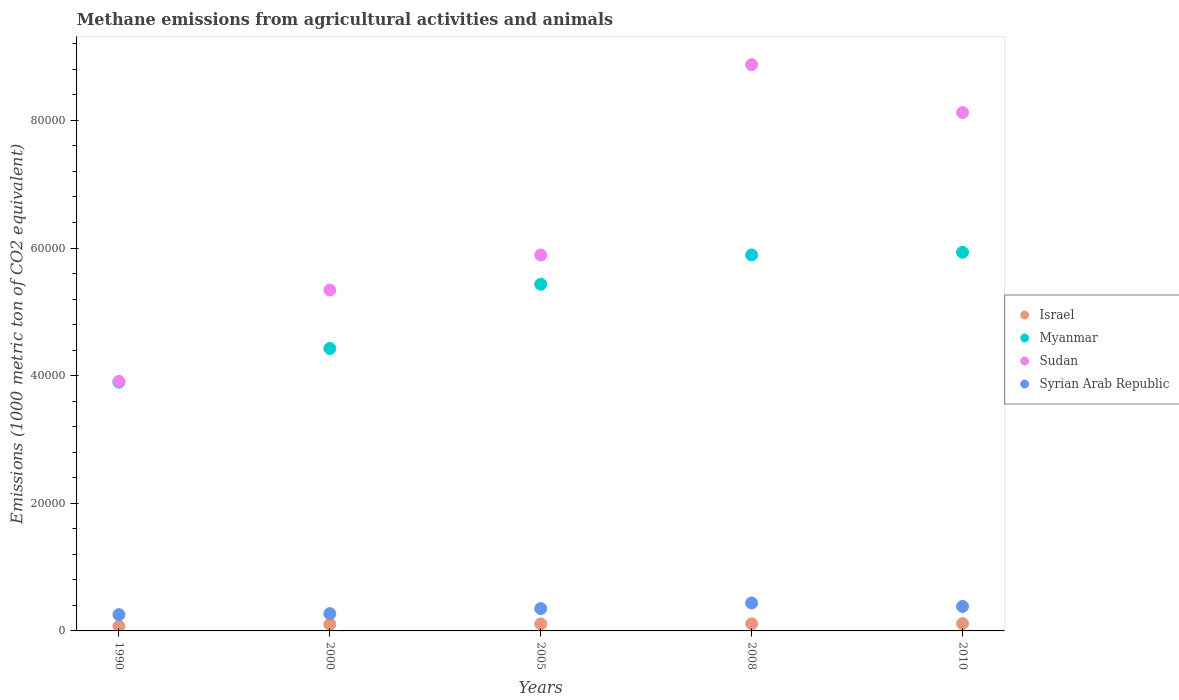Is the number of dotlines equal to the number of legend labels?
Offer a terse response. Yes. What is the amount of methane emitted in Syrian Arab Republic in 2000?
Provide a succinct answer. 2708.8. Across all years, what is the maximum amount of methane emitted in Israel?
Provide a succinct answer. 1145.5. Across all years, what is the minimum amount of methane emitted in Israel?
Your answer should be compact. 737.7. What is the total amount of methane emitted in Israel in the graph?
Give a very brief answer. 5140.4. What is the difference between the amount of methane emitted in Myanmar in 1990 and that in 2000?
Your answer should be compact. -5282. What is the difference between the amount of methane emitted in Sudan in 2000 and the amount of methane emitted in Syrian Arab Republic in 2010?
Your response must be concise. 4.96e+04. What is the average amount of methane emitted in Myanmar per year?
Offer a terse response. 5.12e+04. In the year 2005, what is the difference between the amount of methane emitted in Myanmar and amount of methane emitted in Sudan?
Provide a succinct answer. -4577.7. In how many years, is the amount of methane emitted in Myanmar greater than 4000 1000 metric ton?
Your answer should be very brief. 5. What is the ratio of the amount of methane emitted in Israel in 1990 to that in 2008?
Your answer should be compact. 0.66. Is the amount of methane emitted in Syrian Arab Republic in 1990 less than that in 2010?
Your response must be concise. Yes. Is the difference between the amount of methane emitted in Myanmar in 2000 and 2008 greater than the difference between the amount of methane emitted in Sudan in 2000 and 2008?
Ensure brevity in your answer.  Yes. What is the difference between the highest and the second highest amount of methane emitted in Sudan?
Offer a very short reply. 7508.4. What is the difference between the highest and the lowest amount of methane emitted in Sudan?
Offer a terse response. 4.96e+04. In how many years, is the amount of methane emitted in Israel greater than the average amount of methane emitted in Israel taken over all years?
Provide a short and direct response. 4. Is it the case that in every year, the sum of the amount of methane emitted in Sudan and amount of methane emitted in Syrian Arab Republic  is greater than the amount of methane emitted in Israel?
Your answer should be very brief. Yes. Is the amount of methane emitted in Israel strictly less than the amount of methane emitted in Myanmar over the years?
Give a very brief answer. Yes. How many dotlines are there?
Offer a very short reply. 4. How many years are there in the graph?
Offer a very short reply. 5. Does the graph contain any zero values?
Make the answer very short. No. What is the title of the graph?
Offer a very short reply. Methane emissions from agricultural activities and animals. What is the label or title of the Y-axis?
Your answer should be very brief. Emissions (1000 metric ton of CO2 equivalent). What is the Emissions (1000 metric ton of CO2 equivalent) of Israel in 1990?
Offer a terse response. 737.7. What is the Emissions (1000 metric ton of CO2 equivalent) in Myanmar in 1990?
Make the answer very short. 3.90e+04. What is the Emissions (1000 metric ton of CO2 equivalent) of Sudan in 1990?
Make the answer very short. 3.91e+04. What is the Emissions (1000 metric ton of CO2 equivalent) of Syrian Arab Republic in 1990?
Provide a succinct answer. 2551.7. What is the Emissions (1000 metric ton of CO2 equivalent) of Israel in 2000?
Your response must be concise. 1041.6. What is the Emissions (1000 metric ton of CO2 equivalent) in Myanmar in 2000?
Your answer should be compact. 4.43e+04. What is the Emissions (1000 metric ton of CO2 equivalent) in Sudan in 2000?
Provide a succinct answer. 5.34e+04. What is the Emissions (1000 metric ton of CO2 equivalent) of Syrian Arab Republic in 2000?
Provide a short and direct response. 2708.8. What is the Emissions (1000 metric ton of CO2 equivalent) in Israel in 2005?
Keep it short and to the point. 1095.9. What is the Emissions (1000 metric ton of CO2 equivalent) of Myanmar in 2005?
Provide a succinct answer. 5.43e+04. What is the Emissions (1000 metric ton of CO2 equivalent) of Sudan in 2005?
Your answer should be very brief. 5.89e+04. What is the Emissions (1000 metric ton of CO2 equivalent) of Syrian Arab Republic in 2005?
Your answer should be compact. 3498.3. What is the Emissions (1000 metric ton of CO2 equivalent) of Israel in 2008?
Make the answer very short. 1119.7. What is the Emissions (1000 metric ton of CO2 equivalent) in Myanmar in 2008?
Provide a short and direct response. 5.89e+04. What is the Emissions (1000 metric ton of CO2 equivalent) of Sudan in 2008?
Ensure brevity in your answer.  8.87e+04. What is the Emissions (1000 metric ton of CO2 equivalent) in Syrian Arab Republic in 2008?
Your answer should be compact. 4376.8. What is the Emissions (1000 metric ton of CO2 equivalent) of Israel in 2010?
Your answer should be compact. 1145.5. What is the Emissions (1000 metric ton of CO2 equivalent) in Myanmar in 2010?
Ensure brevity in your answer.  5.93e+04. What is the Emissions (1000 metric ton of CO2 equivalent) in Sudan in 2010?
Offer a very short reply. 8.12e+04. What is the Emissions (1000 metric ton of CO2 equivalent) of Syrian Arab Republic in 2010?
Your answer should be very brief. 3839.8. Across all years, what is the maximum Emissions (1000 metric ton of CO2 equivalent) of Israel?
Offer a very short reply. 1145.5. Across all years, what is the maximum Emissions (1000 metric ton of CO2 equivalent) in Myanmar?
Make the answer very short. 5.93e+04. Across all years, what is the maximum Emissions (1000 metric ton of CO2 equivalent) of Sudan?
Offer a very short reply. 8.87e+04. Across all years, what is the maximum Emissions (1000 metric ton of CO2 equivalent) in Syrian Arab Republic?
Your answer should be compact. 4376.8. Across all years, what is the minimum Emissions (1000 metric ton of CO2 equivalent) in Israel?
Keep it short and to the point. 737.7. Across all years, what is the minimum Emissions (1000 metric ton of CO2 equivalent) of Myanmar?
Your response must be concise. 3.90e+04. Across all years, what is the minimum Emissions (1000 metric ton of CO2 equivalent) in Sudan?
Provide a succinct answer. 3.91e+04. Across all years, what is the minimum Emissions (1000 metric ton of CO2 equivalent) of Syrian Arab Republic?
Your answer should be very brief. 2551.7. What is the total Emissions (1000 metric ton of CO2 equivalent) in Israel in the graph?
Give a very brief answer. 5140.4. What is the total Emissions (1000 metric ton of CO2 equivalent) of Myanmar in the graph?
Provide a succinct answer. 2.56e+05. What is the total Emissions (1000 metric ton of CO2 equivalent) of Sudan in the graph?
Your answer should be very brief. 3.21e+05. What is the total Emissions (1000 metric ton of CO2 equivalent) of Syrian Arab Republic in the graph?
Your answer should be compact. 1.70e+04. What is the difference between the Emissions (1000 metric ton of CO2 equivalent) of Israel in 1990 and that in 2000?
Your answer should be very brief. -303.9. What is the difference between the Emissions (1000 metric ton of CO2 equivalent) in Myanmar in 1990 and that in 2000?
Give a very brief answer. -5282. What is the difference between the Emissions (1000 metric ton of CO2 equivalent) of Sudan in 1990 and that in 2000?
Your answer should be compact. -1.43e+04. What is the difference between the Emissions (1000 metric ton of CO2 equivalent) in Syrian Arab Republic in 1990 and that in 2000?
Make the answer very short. -157.1. What is the difference between the Emissions (1000 metric ton of CO2 equivalent) of Israel in 1990 and that in 2005?
Give a very brief answer. -358.2. What is the difference between the Emissions (1000 metric ton of CO2 equivalent) of Myanmar in 1990 and that in 2005?
Your answer should be compact. -1.53e+04. What is the difference between the Emissions (1000 metric ton of CO2 equivalent) of Sudan in 1990 and that in 2005?
Provide a short and direct response. -1.98e+04. What is the difference between the Emissions (1000 metric ton of CO2 equivalent) of Syrian Arab Republic in 1990 and that in 2005?
Your answer should be compact. -946.6. What is the difference between the Emissions (1000 metric ton of CO2 equivalent) in Israel in 1990 and that in 2008?
Your answer should be compact. -382. What is the difference between the Emissions (1000 metric ton of CO2 equivalent) in Myanmar in 1990 and that in 2008?
Your response must be concise. -1.99e+04. What is the difference between the Emissions (1000 metric ton of CO2 equivalent) in Sudan in 1990 and that in 2008?
Give a very brief answer. -4.96e+04. What is the difference between the Emissions (1000 metric ton of CO2 equivalent) in Syrian Arab Republic in 1990 and that in 2008?
Offer a very short reply. -1825.1. What is the difference between the Emissions (1000 metric ton of CO2 equivalent) of Israel in 1990 and that in 2010?
Keep it short and to the point. -407.8. What is the difference between the Emissions (1000 metric ton of CO2 equivalent) of Myanmar in 1990 and that in 2010?
Ensure brevity in your answer.  -2.04e+04. What is the difference between the Emissions (1000 metric ton of CO2 equivalent) in Sudan in 1990 and that in 2010?
Make the answer very short. -4.21e+04. What is the difference between the Emissions (1000 metric ton of CO2 equivalent) of Syrian Arab Republic in 1990 and that in 2010?
Make the answer very short. -1288.1. What is the difference between the Emissions (1000 metric ton of CO2 equivalent) of Israel in 2000 and that in 2005?
Provide a succinct answer. -54.3. What is the difference between the Emissions (1000 metric ton of CO2 equivalent) in Myanmar in 2000 and that in 2005?
Your response must be concise. -1.01e+04. What is the difference between the Emissions (1000 metric ton of CO2 equivalent) of Sudan in 2000 and that in 2005?
Offer a very short reply. -5487.9. What is the difference between the Emissions (1000 metric ton of CO2 equivalent) in Syrian Arab Republic in 2000 and that in 2005?
Provide a succinct answer. -789.5. What is the difference between the Emissions (1000 metric ton of CO2 equivalent) in Israel in 2000 and that in 2008?
Provide a short and direct response. -78.1. What is the difference between the Emissions (1000 metric ton of CO2 equivalent) in Myanmar in 2000 and that in 2008?
Keep it short and to the point. -1.47e+04. What is the difference between the Emissions (1000 metric ton of CO2 equivalent) of Sudan in 2000 and that in 2008?
Ensure brevity in your answer.  -3.53e+04. What is the difference between the Emissions (1000 metric ton of CO2 equivalent) of Syrian Arab Republic in 2000 and that in 2008?
Provide a short and direct response. -1668. What is the difference between the Emissions (1000 metric ton of CO2 equivalent) of Israel in 2000 and that in 2010?
Provide a short and direct response. -103.9. What is the difference between the Emissions (1000 metric ton of CO2 equivalent) of Myanmar in 2000 and that in 2010?
Make the answer very short. -1.51e+04. What is the difference between the Emissions (1000 metric ton of CO2 equivalent) of Sudan in 2000 and that in 2010?
Offer a very short reply. -2.78e+04. What is the difference between the Emissions (1000 metric ton of CO2 equivalent) in Syrian Arab Republic in 2000 and that in 2010?
Your response must be concise. -1131. What is the difference between the Emissions (1000 metric ton of CO2 equivalent) of Israel in 2005 and that in 2008?
Keep it short and to the point. -23.8. What is the difference between the Emissions (1000 metric ton of CO2 equivalent) in Myanmar in 2005 and that in 2008?
Provide a short and direct response. -4589.9. What is the difference between the Emissions (1000 metric ton of CO2 equivalent) of Sudan in 2005 and that in 2008?
Provide a succinct answer. -2.98e+04. What is the difference between the Emissions (1000 metric ton of CO2 equivalent) of Syrian Arab Republic in 2005 and that in 2008?
Your response must be concise. -878.5. What is the difference between the Emissions (1000 metric ton of CO2 equivalent) in Israel in 2005 and that in 2010?
Provide a succinct answer. -49.6. What is the difference between the Emissions (1000 metric ton of CO2 equivalent) in Myanmar in 2005 and that in 2010?
Your response must be concise. -5009.8. What is the difference between the Emissions (1000 metric ton of CO2 equivalent) of Sudan in 2005 and that in 2010?
Offer a very short reply. -2.23e+04. What is the difference between the Emissions (1000 metric ton of CO2 equivalent) of Syrian Arab Republic in 2005 and that in 2010?
Offer a very short reply. -341.5. What is the difference between the Emissions (1000 metric ton of CO2 equivalent) in Israel in 2008 and that in 2010?
Ensure brevity in your answer.  -25.8. What is the difference between the Emissions (1000 metric ton of CO2 equivalent) in Myanmar in 2008 and that in 2010?
Your answer should be compact. -419.9. What is the difference between the Emissions (1000 metric ton of CO2 equivalent) in Sudan in 2008 and that in 2010?
Your answer should be compact. 7508.4. What is the difference between the Emissions (1000 metric ton of CO2 equivalent) of Syrian Arab Republic in 2008 and that in 2010?
Give a very brief answer. 537. What is the difference between the Emissions (1000 metric ton of CO2 equivalent) of Israel in 1990 and the Emissions (1000 metric ton of CO2 equivalent) of Myanmar in 2000?
Provide a short and direct response. -4.35e+04. What is the difference between the Emissions (1000 metric ton of CO2 equivalent) in Israel in 1990 and the Emissions (1000 metric ton of CO2 equivalent) in Sudan in 2000?
Provide a short and direct response. -5.27e+04. What is the difference between the Emissions (1000 metric ton of CO2 equivalent) of Israel in 1990 and the Emissions (1000 metric ton of CO2 equivalent) of Syrian Arab Republic in 2000?
Offer a very short reply. -1971.1. What is the difference between the Emissions (1000 metric ton of CO2 equivalent) in Myanmar in 1990 and the Emissions (1000 metric ton of CO2 equivalent) in Sudan in 2000?
Make the answer very short. -1.44e+04. What is the difference between the Emissions (1000 metric ton of CO2 equivalent) in Myanmar in 1990 and the Emissions (1000 metric ton of CO2 equivalent) in Syrian Arab Republic in 2000?
Ensure brevity in your answer.  3.63e+04. What is the difference between the Emissions (1000 metric ton of CO2 equivalent) in Sudan in 1990 and the Emissions (1000 metric ton of CO2 equivalent) in Syrian Arab Republic in 2000?
Provide a succinct answer. 3.64e+04. What is the difference between the Emissions (1000 metric ton of CO2 equivalent) of Israel in 1990 and the Emissions (1000 metric ton of CO2 equivalent) of Myanmar in 2005?
Make the answer very short. -5.36e+04. What is the difference between the Emissions (1000 metric ton of CO2 equivalent) of Israel in 1990 and the Emissions (1000 metric ton of CO2 equivalent) of Sudan in 2005?
Keep it short and to the point. -5.82e+04. What is the difference between the Emissions (1000 metric ton of CO2 equivalent) of Israel in 1990 and the Emissions (1000 metric ton of CO2 equivalent) of Syrian Arab Republic in 2005?
Your response must be concise. -2760.6. What is the difference between the Emissions (1000 metric ton of CO2 equivalent) in Myanmar in 1990 and the Emissions (1000 metric ton of CO2 equivalent) in Sudan in 2005?
Give a very brief answer. -1.99e+04. What is the difference between the Emissions (1000 metric ton of CO2 equivalent) of Myanmar in 1990 and the Emissions (1000 metric ton of CO2 equivalent) of Syrian Arab Republic in 2005?
Provide a short and direct response. 3.55e+04. What is the difference between the Emissions (1000 metric ton of CO2 equivalent) in Sudan in 1990 and the Emissions (1000 metric ton of CO2 equivalent) in Syrian Arab Republic in 2005?
Provide a short and direct response. 3.56e+04. What is the difference between the Emissions (1000 metric ton of CO2 equivalent) of Israel in 1990 and the Emissions (1000 metric ton of CO2 equivalent) of Myanmar in 2008?
Provide a succinct answer. -5.82e+04. What is the difference between the Emissions (1000 metric ton of CO2 equivalent) of Israel in 1990 and the Emissions (1000 metric ton of CO2 equivalent) of Sudan in 2008?
Make the answer very short. -8.80e+04. What is the difference between the Emissions (1000 metric ton of CO2 equivalent) in Israel in 1990 and the Emissions (1000 metric ton of CO2 equivalent) in Syrian Arab Republic in 2008?
Make the answer very short. -3639.1. What is the difference between the Emissions (1000 metric ton of CO2 equivalent) in Myanmar in 1990 and the Emissions (1000 metric ton of CO2 equivalent) in Sudan in 2008?
Your answer should be very brief. -4.98e+04. What is the difference between the Emissions (1000 metric ton of CO2 equivalent) of Myanmar in 1990 and the Emissions (1000 metric ton of CO2 equivalent) of Syrian Arab Republic in 2008?
Provide a succinct answer. 3.46e+04. What is the difference between the Emissions (1000 metric ton of CO2 equivalent) in Sudan in 1990 and the Emissions (1000 metric ton of CO2 equivalent) in Syrian Arab Republic in 2008?
Offer a very short reply. 3.47e+04. What is the difference between the Emissions (1000 metric ton of CO2 equivalent) in Israel in 1990 and the Emissions (1000 metric ton of CO2 equivalent) in Myanmar in 2010?
Make the answer very short. -5.86e+04. What is the difference between the Emissions (1000 metric ton of CO2 equivalent) of Israel in 1990 and the Emissions (1000 metric ton of CO2 equivalent) of Sudan in 2010?
Your response must be concise. -8.05e+04. What is the difference between the Emissions (1000 metric ton of CO2 equivalent) of Israel in 1990 and the Emissions (1000 metric ton of CO2 equivalent) of Syrian Arab Republic in 2010?
Your answer should be very brief. -3102.1. What is the difference between the Emissions (1000 metric ton of CO2 equivalent) of Myanmar in 1990 and the Emissions (1000 metric ton of CO2 equivalent) of Sudan in 2010?
Offer a very short reply. -4.22e+04. What is the difference between the Emissions (1000 metric ton of CO2 equivalent) in Myanmar in 1990 and the Emissions (1000 metric ton of CO2 equivalent) in Syrian Arab Republic in 2010?
Offer a very short reply. 3.51e+04. What is the difference between the Emissions (1000 metric ton of CO2 equivalent) in Sudan in 1990 and the Emissions (1000 metric ton of CO2 equivalent) in Syrian Arab Republic in 2010?
Provide a succinct answer. 3.53e+04. What is the difference between the Emissions (1000 metric ton of CO2 equivalent) in Israel in 2000 and the Emissions (1000 metric ton of CO2 equivalent) in Myanmar in 2005?
Ensure brevity in your answer.  -5.33e+04. What is the difference between the Emissions (1000 metric ton of CO2 equivalent) in Israel in 2000 and the Emissions (1000 metric ton of CO2 equivalent) in Sudan in 2005?
Offer a terse response. -5.79e+04. What is the difference between the Emissions (1000 metric ton of CO2 equivalent) of Israel in 2000 and the Emissions (1000 metric ton of CO2 equivalent) of Syrian Arab Republic in 2005?
Your response must be concise. -2456.7. What is the difference between the Emissions (1000 metric ton of CO2 equivalent) in Myanmar in 2000 and the Emissions (1000 metric ton of CO2 equivalent) in Sudan in 2005?
Make the answer very short. -1.46e+04. What is the difference between the Emissions (1000 metric ton of CO2 equivalent) in Myanmar in 2000 and the Emissions (1000 metric ton of CO2 equivalent) in Syrian Arab Republic in 2005?
Make the answer very short. 4.08e+04. What is the difference between the Emissions (1000 metric ton of CO2 equivalent) of Sudan in 2000 and the Emissions (1000 metric ton of CO2 equivalent) of Syrian Arab Republic in 2005?
Offer a very short reply. 4.99e+04. What is the difference between the Emissions (1000 metric ton of CO2 equivalent) in Israel in 2000 and the Emissions (1000 metric ton of CO2 equivalent) in Myanmar in 2008?
Your answer should be compact. -5.79e+04. What is the difference between the Emissions (1000 metric ton of CO2 equivalent) in Israel in 2000 and the Emissions (1000 metric ton of CO2 equivalent) in Sudan in 2008?
Your answer should be compact. -8.77e+04. What is the difference between the Emissions (1000 metric ton of CO2 equivalent) in Israel in 2000 and the Emissions (1000 metric ton of CO2 equivalent) in Syrian Arab Republic in 2008?
Provide a short and direct response. -3335.2. What is the difference between the Emissions (1000 metric ton of CO2 equivalent) of Myanmar in 2000 and the Emissions (1000 metric ton of CO2 equivalent) of Sudan in 2008?
Offer a very short reply. -4.45e+04. What is the difference between the Emissions (1000 metric ton of CO2 equivalent) of Myanmar in 2000 and the Emissions (1000 metric ton of CO2 equivalent) of Syrian Arab Republic in 2008?
Keep it short and to the point. 3.99e+04. What is the difference between the Emissions (1000 metric ton of CO2 equivalent) in Sudan in 2000 and the Emissions (1000 metric ton of CO2 equivalent) in Syrian Arab Republic in 2008?
Provide a short and direct response. 4.90e+04. What is the difference between the Emissions (1000 metric ton of CO2 equivalent) of Israel in 2000 and the Emissions (1000 metric ton of CO2 equivalent) of Myanmar in 2010?
Make the answer very short. -5.83e+04. What is the difference between the Emissions (1000 metric ton of CO2 equivalent) of Israel in 2000 and the Emissions (1000 metric ton of CO2 equivalent) of Sudan in 2010?
Provide a short and direct response. -8.02e+04. What is the difference between the Emissions (1000 metric ton of CO2 equivalent) of Israel in 2000 and the Emissions (1000 metric ton of CO2 equivalent) of Syrian Arab Republic in 2010?
Provide a short and direct response. -2798.2. What is the difference between the Emissions (1000 metric ton of CO2 equivalent) in Myanmar in 2000 and the Emissions (1000 metric ton of CO2 equivalent) in Sudan in 2010?
Give a very brief answer. -3.70e+04. What is the difference between the Emissions (1000 metric ton of CO2 equivalent) of Myanmar in 2000 and the Emissions (1000 metric ton of CO2 equivalent) of Syrian Arab Republic in 2010?
Provide a succinct answer. 4.04e+04. What is the difference between the Emissions (1000 metric ton of CO2 equivalent) of Sudan in 2000 and the Emissions (1000 metric ton of CO2 equivalent) of Syrian Arab Republic in 2010?
Provide a short and direct response. 4.96e+04. What is the difference between the Emissions (1000 metric ton of CO2 equivalent) in Israel in 2005 and the Emissions (1000 metric ton of CO2 equivalent) in Myanmar in 2008?
Provide a succinct answer. -5.78e+04. What is the difference between the Emissions (1000 metric ton of CO2 equivalent) of Israel in 2005 and the Emissions (1000 metric ton of CO2 equivalent) of Sudan in 2008?
Make the answer very short. -8.76e+04. What is the difference between the Emissions (1000 metric ton of CO2 equivalent) in Israel in 2005 and the Emissions (1000 metric ton of CO2 equivalent) in Syrian Arab Republic in 2008?
Your response must be concise. -3280.9. What is the difference between the Emissions (1000 metric ton of CO2 equivalent) of Myanmar in 2005 and the Emissions (1000 metric ton of CO2 equivalent) of Sudan in 2008?
Provide a short and direct response. -3.44e+04. What is the difference between the Emissions (1000 metric ton of CO2 equivalent) in Myanmar in 2005 and the Emissions (1000 metric ton of CO2 equivalent) in Syrian Arab Republic in 2008?
Make the answer very short. 4.99e+04. What is the difference between the Emissions (1000 metric ton of CO2 equivalent) in Sudan in 2005 and the Emissions (1000 metric ton of CO2 equivalent) in Syrian Arab Republic in 2008?
Give a very brief answer. 5.45e+04. What is the difference between the Emissions (1000 metric ton of CO2 equivalent) of Israel in 2005 and the Emissions (1000 metric ton of CO2 equivalent) of Myanmar in 2010?
Give a very brief answer. -5.82e+04. What is the difference between the Emissions (1000 metric ton of CO2 equivalent) of Israel in 2005 and the Emissions (1000 metric ton of CO2 equivalent) of Sudan in 2010?
Offer a very short reply. -8.01e+04. What is the difference between the Emissions (1000 metric ton of CO2 equivalent) of Israel in 2005 and the Emissions (1000 metric ton of CO2 equivalent) of Syrian Arab Republic in 2010?
Make the answer very short. -2743.9. What is the difference between the Emissions (1000 metric ton of CO2 equivalent) of Myanmar in 2005 and the Emissions (1000 metric ton of CO2 equivalent) of Sudan in 2010?
Ensure brevity in your answer.  -2.69e+04. What is the difference between the Emissions (1000 metric ton of CO2 equivalent) of Myanmar in 2005 and the Emissions (1000 metric ton of CO2 equivalent) of Syrian Arab Republic in 2010?
Your answer should be compact. 5.05e+04. What is the difference between the Emissions (1000 metric ton of CO2 equivalent) in Sudan in 2005 and the Emissions (1000 metric ton of CO2 equivalent) in Syrian Arab Republic in 2010?
Provide a short and direct response. 5.51e+04. What is the difference between the Emissions (1000 metric ton of CO2 equivalent) of Israel in 2008 and the Emissions (1000 metric ton of CO2 equivalent) of Myanmar in 2010?
Your response must be concise. -5.82e+04. What is the difference between the Emissions (1000 metric ton of CO2 equivalent) in Israel in 2008 and the Emissions (1000 metric ton of CO2 equivalent) in Sudan in 2010?
Make the answer very short. -8.01e+04. What is the difference between the Emissions (1000 metric ton of CO2 equivalent) of Israel in 2008 and the Emissions (1000 metric ton of CO2 equivalent) of Syrian Arab Republic in 2010?
Provide a short and direct response. -2720.1. What is the difference between the Emissions (1000 metric ton of CO2 equivalent) in Myanmar in 2008 and the Emissions (1000 metric ton of CO2 equivalent) in Sudan in 2010?
Offer a terse response. -2.23e+04. What is the difference between the Emissions (1000 metric ton of CO2 equivalent) in Myanmar in 2008 and the Emissions (1000 metric ton of CO2 equivalent) in Syrian Arab Republic in 2010?
Your answer should be compact. 5.51e+04. What is the difference between the Emissions (1000 metric ton of CO2 equivalent) in Sudan in 2008 and the Emissions (1000 metric ton of CO2 equivalent) in Syrian Arab Republic in 2010?
Keep it short and to the point. 8.49e+04. What is the average Emissions (1000 metric ton of CO2 equivalent) of Israel per year?
Ensure brevity in your answer.  1028.08. What is the average Emissions (1000 metric ton of CO2 equivalent) of Myanmar per year?
Your response must be concise. 5.12e+04. What is the average Emissions (1000 metric ton of CO2 equivalent) in Sudan per year?
Provide a short and direct response. 6.43e+04. What is the average Emissions (1000 metric ton of CO2 equivalent) in Syrian Arab Republic per year?
Provide a short and direct response. 3395.08. In the year 1990, what is the difference between the Emissions (1000 metric ton of CO2 equivalent) in Israel and Emissions (1000 metric ton of CO2 equivalent) in Myanmar?
Your answer should be compact. -3.82e+04. In the year 1990, what is the difference between the Emissions (1000 metric ton of CO2 equivalent) in Israel and Emissions (1000 metric ton of CO2 equivalent) in Sudan?
Give a very brief answer. -3.84e+04. In the year 1990, what is the difference between the Emissions (1000 metric ton of CO2 equivalent) of Israel and Emissions (1000 metric ton of CO2 equivalent) of Syrian Arab Republic?
Give a very brief answer. -1814. In the year 1990, what is the difference between the Emissions (1000 metric ton of CO2 equivalent) in Myanmar and Emissions (1000 metric ton of CO2 equivalent) in Sudan?
Ensure brevity in your answer.  -123.6. In the year 1990, what is the difference between the Emissions (1000 metric ton of CO2 equivalent) in Myanmar and Emissions (1000 metric ton of CO2 equivalent) in Syrian Arab Republic?
Offer a very short reply. 3.64e+04. In the year 1990, what is the difference between the Emissions (1000 metric ton of CO2 equivalent) of Sudan and Emissions (1000 metric ton of CO2 equivalent) of Syrian Arab Republic?
Your answer should be very brief. 3.66e+04. In the year 2000, what is the difference between the Emissions (1000 metric ton of CO2 equivalent) in Israel and Emissions (1000 metric ton of CO2 equivalent) in Myanmar?
Provide a succinct answer. -4.32e+04. In the year 2000, what is the difference between the Emissions (1000 metric ton of CO2 equivalent) of Israel and Emissions (1000 metric ton of CO2 equivalent) of Sudan?
Provide a succinct answer. -5.24e+04. In the year 2000, what is the difference between the Emissions (1000 metric ton of CO2 equivalent) in Israel and Emissions (1000 metric ton of CO2 equivalent) in Syrian Arab Republic?
Your answer should be very brief. -1667.2. In the year 2000, what is the difference between the Emissions (1000 metric ton of CO2 equivalent) in Myanmar and Emissions (1000 metric ton of CO2 equivalent) in Sudan?
Ensure brevity in your answer.  -9153.2. In the year 2000, what is the difference between the Emissions (1000 metric ton of CO2 equivalent) of Myanmar and Emissions (1000 metric ton of CO2 equivalent) of Syrian Arab Republic?
Make the answer very short. 4.16e+04. In the year 2000, what is the difference between the Emissions (1000 metric ton of CO2 equivalent) of Sudan and Emissions (1000 metric ton of CO2 equivalent) of Syrian Arab Republic?
Provide a short and direct response. 5.07e+04. In the year 2005, what is the difference between the Emissions (1000 metric ton of CO2 equivalent) of Israel and Emissions (1000 metric ton of CO2 equivalent) of Myanmar?
Your answer should be very brief. -5.32e+04. In the year 2005, what is the difference between the Emissions (1000 metric ton of CO2 equivalent) of Israel and Emissions (1000 metric ton of CO2 equivalent) of Sudan?
Your answer should be compact. -5.78e+04. In the year 2005, what is the difference between the Emissions (1000 metric ton of CO2 equivalent) in Israel and Emissions (1000 metric ton of CO2 equivalent) in Syrian Arab Republic?
Give a very brief answer. -2402.4. In the year 2005, what is the difference between the Emissions (1000 metric ton of CO2 equivalent) of Myanmar and Emissions (1000 metric ton of CO2 equivalent) of Sudan?
Give a very brief answer. -4577.7. In the year 2005, what is the difference between the Emissions (1000 metric ton of CO2 equivalent) in Myanmar and Emissions (1000 metric ton of CO2 equivalent) in Syrian Arab Republic?
Ensure brevity in your answer.  5.08e+04. In the year 2005, what is the difference between the Emissions (1000 metric ton of CO2 equivalent) in Sudan and Emissions (1000 metric ton of CO2 equivalent) in Syrian Arab Republic?
Provide a short and direct response. 5.54e+04. In the year 2008, what is the difference between the Emissions (1000 metric ton of CO2 equivalent) of Israel and Emissions (1000 metric ton of CO2 equivalent) of Myanmar?
Give a very brief answer. -5.78e+04. In the year 2008, what is the difference between the Emissions (1000 metric ton of CO2 equivalent) of Israel and Emissions (1000 metric ton of CO2 equivalent) of Sudan?
Provide a short and direct response. -8.76e+04. In the year 2008, what is the difference between the Emissions (1000 metric ton of CO2 equivalent) of Israel and Emissions (1000 metric ton of CO2 equivalent) of Syrian Arab Republic?
Offer a terse response. -3257.1. In the year 2008, what is the difference between the Emissions (1000 metric ton of CO2 equivalent) in Myanmar and Emissions (1000 metric ton of CO2 equivalent) in Sudan?
Your response must be concise. -2.98e+04. In the year 2008, what is the difference between the Emissions (1000 metric ton of CO2 equivalent) in Myanmar and Emissions (1000 metric ton of CO2 equivalent) in Syrian Arab Republic?
Offer a very short reply. 5.45e+04. In the year 2008, what is the difference between the Emissions (1000 metric ton of CO2 equivalent) of Sudan and Emissions (1000 metric ton of CO2 equivalent) of Syrian Arab Republic?
Provide a succinct answer. 8.44e+04. In the year 2010, what is the difference between the Emissions (1000 metric ton of CO2 equivalent) in Israel and Emissions (1000 metric ton of CO2 equivalent) in Myanmar?
Your answer should be compact. -5.82e+04. In the year 2010, what is the difference between the Emissions (1000 metric ton of CO2 equivalent) in Israel and Emissions (1000 metric ton of CO2 equivalent) in Sudan?
Ensure brevity in your answer.  -8.01e+04. In the year 2010, what is the difference between the Emissions (1000 metric ton of CO2 equivalent) in Israel and Emissions (1000 metric ton of CO2 equivalent) in Syrian Arab Republic?
Offer a very short reply. -2694.3. In the year 2010, what is the difference between the Emissions (1000 metric ton of CO2 equivalent) of Myanmar and Emissions (1000 metric ton of CO2 equivalent) of Sudan?
Your answer should be compact. -2.19e+04. In the year 2010, what is the difference between the Emissions (1000 metric ton of CO2 equivalent) in Myanmar and Emissions (1000 metric ton of CO2 equivalent) in Syrian Arab Republic?
Offer a very short reply. 5.55e+04. In the year 2010, what is the difference between the Emissions (1000 metric ton of CO2 equivalent) of Sudan and Emissions (1000 metric ton of CO2 equivalent) of Syrian Arab Republic?
Keep it short and to the point. 7.74e+04. What is the ratio of the Emissions (1000 metric ton of CO2 equivalent) of Israel in 1990 to that in 2000?
Your answer should be compact. 0.71. What is the ratio of the Emissions (1000 metric ton of CO2 equivalent) in Myanmar in 1990 to that in 2000?
Offer a terse response. 0.88. What is the ratio of the Emissions (1000 metric ton of CO2 equivalent) in Sudan in 1990 to that in 2000?
Ensure brevity in your answer.  0.73. What is the ratio of the Emissions (1000 metric ton of CO2 equivalent) in Syrian Arab Republic in 1990 to that in 2000?
Provide a short and direct response. 0.94. What is the ratio of the Emissions (1000 metric ton of CO2 equivalent) in Israel in 1990 to that in 2005?
Ensure brevity in your answer.  0.67. What is the ratio of the Emissions (1000 metric ton of CO2 equivalent) in Myanmar in 1990 to that in 2005?
Provide a succinct answer. 0.72. What is the ratio of the Emissions (1000 metric ton of CO2 equivalent) of Sudan in 1990 to that in 2005?
Keep it short and to the point. 0.66. What is the ratio of the Emissions (1000 metric ton of CO2 equivalent) in Syrian Arab Republic in 1990 to that in 2005?
Provide a succinct answer. 0.73. What is the ratio of the Emissions (1000 metric ton of CO2 equivalent) in Israel in 1990 to that in 2008?
Give a very brief answer. 0.66. What is the ratio of the Emissions (1000 metric ton of CO2 equivalent) of Myanmar in 1990 to that in 2008?
Provide a short and direct response. 0.66. What is the ratio of the Emissions (1000 metric ton of CO2 equivalent) in Sudan in 1990 to that in 2008?
Your answer should be compact. 0.44. What is the ratio of the Emissions (1000 metric ton of CO2 equivalent) of Syrian Arab Republic in 1990 to that in 2008?
Ensure brevity in your answer.  0.58. What is the ratio of the Emissions (1000 metric ton of CO2 equivalent) of Israel in 1990 to that in 2010?
Your response must be concise. 0.64. What is the ratio of the Emissions (1000 metric ton of CO2 equivalent) in Myanmar in 1990 to that in 2010?
Make the answer very short. 0.66. What is the ratio of the Emissions (1000 metric ton of CO2 equivalent) of Sudan in 1990 to that in 2010?
Offer a terse response. 0.48. What is the ratio of the Emissions (1000 metric ton of CO2 equivalent) of Syrian Arab Republic in 1990 to that in 2010?
Provide a succinct answer. 0.66. What is the ratio of the Emissions (1000 metric ton of CO2 equivalent) of Israel in 2000 to that in 2005?
Ensure brevity in your answer.  0.95. What is the ratio of the Emissions (1000 metric ton of CO2 equivalent) of Myanmar in 2000 to that in 2005?
Provide a succinct answer. 0.81. What is the ratio of the Emissions (1000 metric ton of CO2 equivalent) of Sudan in 2000 to that in 2005?
Offer a very short reply. 0.91. What is the ratio of the Emissions (1000 metric ton of CO2 equivalent) of Syrian Arab Republic in 2000 to that in 2005?
Your answer should be very brief. 0.77. What is the ratio of the Emissions (1000 metric ton of CO2 equivalent) of Israel in 2000 to that in 2008?
Make the answer very short. 0.93. What is the ratio of the Emissions (1000 metric ton of CO2 equivalent) in Myanmar in 2000 to that in 2008?
Offer a terse response. 0.75. What is the ratio of the Emissions (1000 metric ton of CO2 equivalent) of Sudan in 2000 to that in 2008?
Your response must be concise. 0.6. What is the ratio of the Emissions (1000 metric ton of CO2 equivalent) of Syrian Arab Republic in 2000 to that in 2008?
Ensure brevity in your answer.  0.62. What is the ratio of the Emissions (1000 metric ton of CO2 equivalent) of Israel in 2000 to that in 2010?
Provide a succinct answer. 0.91. What is the ratio of the Emissions (1000 metric ton of CO2 equivalent) of Myanmar in 2000 to that in 2010?
Provide a succinct answer. 0.75. What is the ratio of the Emissions (1000 metric ton of CO2 equivalent) of Sudan in 2000 to that in 2010?
Your response must be concise. 0.66. What is the ratio of the Emissions (1000 metric ton of CO2 equivalent) in Syrian Arab Republic in 2000 to that in 2010?
Offer a very short reply. 0.71. What is the ratio of the Emissions (1000 metric ton of CO2 equivalent) of Israel in 2005 to that in 2008?
Keep it short and to the point. 0.98. What is the ratio of the Emissions (1000 metric ton of CO2 equivalent) of Myanmar in 2005 to that in 2008?
Your answer should be very brief. 0.92. What is the ratio of the Emissions (1000 metric ton of CO2 equivalent) in Sudan in 2005 to that in 2008?
Give a very brief answer. 0.66. What is the ratio of the Emissions (1000 metric ton of CO2 equivalent) of Syrian Arab Republic in 2005 to that in 2008?
Make the answer very short. 0.8. What is the ratio of the Emissions (1000 metric ton of CO2 equivalent) of Israel in 2005 to that in 2010?
Provide a short and direct response. 0.96. What is the ratio of the Emissions (1000 metric ton of CO2 equivalent) in Myanmar in 2005 to that in 2010?
Your answer should be very brief. 0.92. What is the ratio of the Emissions (1000 metric ton of CO2 equivalent) in Sudan in 2005 to that in 2010?
Your response must be concise. 0.73. What is the ratio of the Emissions (1000 metric ton of CO2 equivalent) of Syrian Arab Republic in 2005 to that in 2010?
Keep it short and to the point. 0.91. What is the ratio of the Emissions (1000 metric ton of CO2 equivalent) of Israel in 2008 to that in 2010?
Provide a succinct answer. 0.98. What is the ratio of the Emissions (1000 metric ton of CO2 equivalent) of Myanmar in 2008 to that in 2010?
Your response must be concise. 0.99. What is the ratio of the Emissions (1000 metric ton of CO2 equivalent) in Sudan in 2008 to that in 2010?
Ensure brevity in your answer.  1.09. What is the ratio of the Emissions (1000 metric ton of CO2 equivalent) of Syrian Arab Republic in 2008 to that in 2010?
Make the answer very short. 1.14. What is the difference between the highest and the second highest Emissions (1000 metric ton of CO2 equivalent) in Israel?
Your response must be concise. 25.8. What is the difference between the highest and the second highest Emissions (1000 metric ton of CO2 equivalent) of Myanmar?
Ensure brevity in your answer.  419.9. What is the difference between the highest and the second highest Emissions (1000 metric ton of CO2 equivalent) of Sudan?
Offer a terse response. 7508.4. What is the difference between the highest and the second highest Emissions (1000 metric ton of CO2 equivalent) in Syrian Arab Republic?
Give a very brief answer. 537. What is the difference between the highest and the lowest Emissions (1000 metric ton of CO2 equivalent) of Israel?
Your response must be concise. 407.8. What is the difference between the highest and the lowest Emissions (1000 metric ton of CO2 equivalent) in Myanmar?
Your answer should be compact. 2.04e+04. What is the difference between the highest and the lowest Emissions (1000 metric ton of CO2 equivalent) in Sudan?
Ensure brevity in your answer.  4.96e+04. What is the difference between the highest and the lowest Emissions (1000 metric ton of CO2 equivalent) in Syrian Arab Republic?
Your answer should be very brief. 1825.1. 